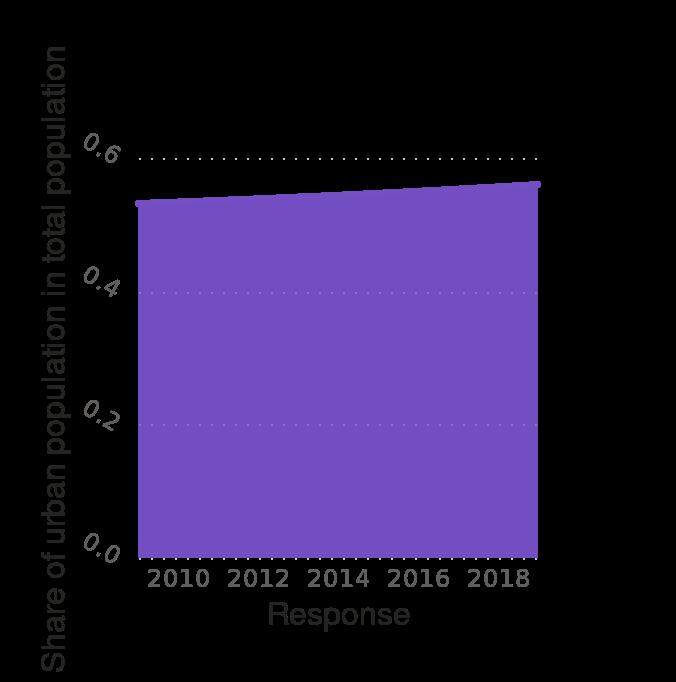<image>
What does the x-axis represent in the graph?  The x-axis represents the response. please summary the statistics and relations of the chart From 2010 to 2018 there has been an increase in the share of urban population in the total population. Each year has seen a steady increase. What was the total population in 2010?  The description does not provide information about the total population in 2010.  